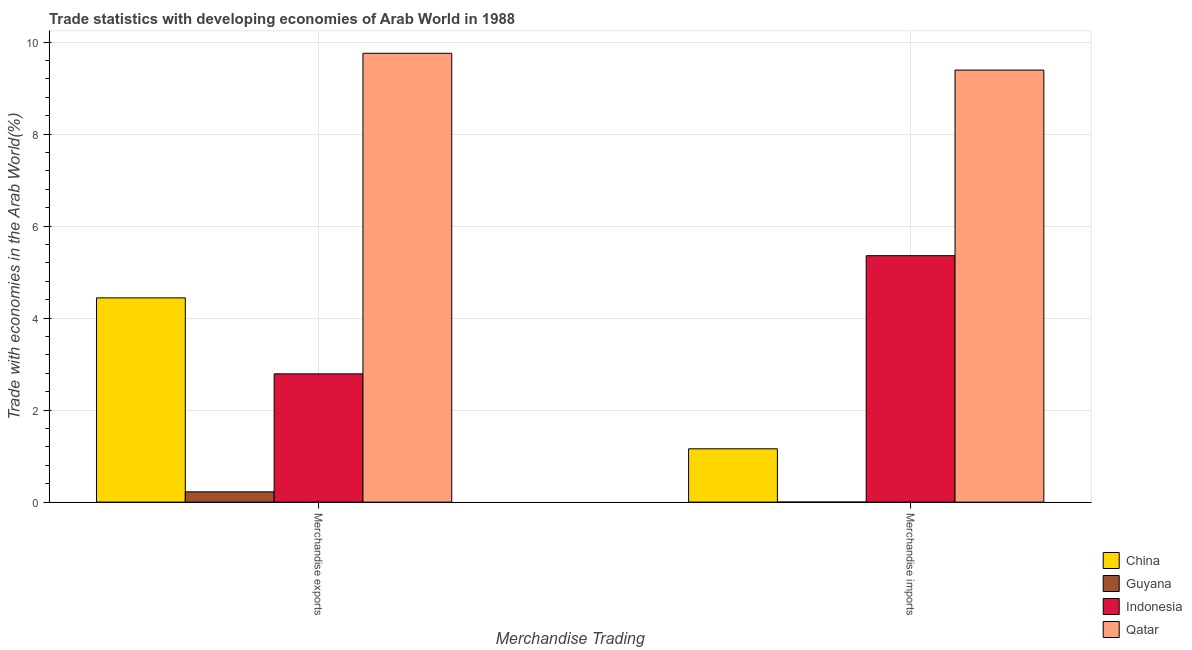How many different coloured bars are there?
Provide a short and direct response. 4. What is the merchandise exports in Qatar?
Ensure brevity in your answer.  9.76. Across all countries, what is the maximum merchandise imports?
Make the answer very short. 9.39. Across all countries, what is the minimum merchandise exports?
Offer a terse response. 0.22. In which country was the merchandise imports maximum?
Provide a short and direct response. Qatar. In which country was the merchandise imports minimum?
Give a very brief answer. Guyana. What is the total merchandise imports in the graph?
Provide a succinct answer. 15.91. What is the difference between the merchandise imports in Indonesia and that in Qatar?
Offer a terse response. -4.04. What is the difference between the merchandise imports in Qatar and the merchandise exports in Indonesia?
Provide a short and direct response. 6.61. What is the average merchandise exports per country?
Provide a short and direct response. 4.3. What is the difference between the merchandise imports and merchandise exports in China?
Offer a very short reply. -3.28. In how many countries, is the merchandise imports greater than 0.4 %?
Provide a short and direct response. 3. What is the ratio of the merchandise exports in Qatar to that in Guyana?
Ensure brevity in your answer.  43.6. Is the merchandise exports in China less than that in Qatar?
Provide a short and direct response. Yes. What does the 4th bar from the left in Merchandise imports represents?
Give a very brief answer. Qatar. What does the 3rd bar from the right in Merchandise exports represents?
Give a very brief answer. Guyana. Are all the bars in the graph horizontal?
Offer a terse response. No. What is the difference between two consecutive major ticks on the Y-axis?
Give a very brief answer. 2. Are the values on the major ticks of Y-axis written in scientific E-notation?
Keep it short and to the point. No. How many legend labels are there?
Make the answer very short. 4. How are the legend labels stacked?
Your answer should be very brief. Vertical. What is the title of the graph?
Make the answer very short. Trade statistics with developing economies of Arab World in 1988. Does "Sub-Saharan Africa (all income levels)" appear as one of the legend labels in the graph?
Offer a terse response. No. What is the label or title of the X-axis?
Your answer should be very brief. Merchandise Trading. What is the label or title of the Y-axis?
Provide a succinct answer. Trade with economies in the Arab World(%). What is the Trade with economies in the Arab World(%) in China in Merchandise exports?
Provide a succinct answer. 4.44. What is the Trade with economies in the Arab World(%) of Guyana in Merchandise exports?
Provide a succinct answer. 0.22. What is the Trade with economies in the Arab World(%) in Indonesia in Merchandise exports?
Provide a short and direct response. 2.79. What is the Trade with economies in the Arab World(%) in Qatar in Merchandise exports?
Provide a short and direct response. 9.76. What is the Trade with economies in the Arab World(%) in China in Merchandise imports?
Your response must be concise. 1.16. What is the Trade with economies in the Arab World(%) of Guyana in Merchandise imports?
Provide a short and direct response. 0. What is the Trade with economies in the Arab World(%) of Indonesia in Merchandise imports?
Ensure brevity in your answer.  5.36. What is the Trade with economies in the Arab World(%) of Qatar in Merchandise imports?
Your answer should be very brief. 9.39. Across all Merchandise Trading, what is the maximum Trade with economies in the Arab World(%) in China?
Provide a succinct answer. 4.44. Across all Merchandise Trading, what is the maximum Trade with economies in the Arab World(%) in Guyana?
Offer a very short reply. 0.22. Across all Merchandise Trading, what is the maximum Trade with economies in the Arab World(%) in Indonesia?
Ensure brevity in your answer.  5.36. Across all Merchandise Trading, what is the maximum Trade with economies in the Arab World(%) in Qatar?
Keep it short and to the point. 9.76. Across all Merchandise Trading, what is the minimum Trade with economies in the Arab World(%) in China?
Offer a terse response. 1.16. Across all Merchandise Trading, what is the minimum Trade with economies in the Arab World(%) in Guyana?
Give a very brief answer. 0. Across all Merchandise Trading, what is the minimum Trade with economies in the Arab World(%) of Indonesia?
Your answer should be very brief. 2.79. Across all Merchandise Trading, what is the minimum Trade with economies in the Arab World(%) of Qatar?
Offer a terse response. 9.39. What is the total Trade with economies in the Arab World(%) in China in the graph?
Offer a terse response. 5.6. What is the total Trade with economies in the Arab World(%) in Guyana in the graph?
Your answer should be very brief. 0.22. What is the total Trade with economies in the Arab World(%) of Indonesia in the graph?
Offer a terse response. 8.15. What is the total Trade with economies in the Arab World(%) in Qatar in the graph?
Provide a short and direct response. 19.15. What is the difference between the Trade with economies in the Arab World(%) in China in Merchandise exports and that in Merchandise imports?
Offer a terse response. 3.28. What is the difference between the Trade with economies in the Arab World(%) of Guyana in Merchandise exports and that in Merchandise imports?
Keep it short and to the point. 0.22. What is the difference between the Trade with economies in the Arab World(%) of Indonesia in Merchandise exports and that in Merchandise imports?
Keep it short and to the point. -2.57. What is the difference between the Trade with economies in the Arab World(%) in Qatar in Merchandise exports and that in Merchandise imports?
Ensure brevity in your answer.  0.37. What is the difference between the Trade with economies in the Arab World(%) of China in Merchandise exports and the Trade with economies in the Arab World(%) of Guyana in Merchandise imports?
Provide a short and direct response. 4.44. What is the difference between the Trade with economies in the Arab World(%) in China in Merchandise exports and the Trade with economies in the Arab World(%) in Indonesia in Merchandise imports?
Provide a short and direct response. -0.92. What is the difference between the Trade with economies in the Arab World(%) of China in Merchandise exports and the Trade with economies in the Arab World(%) of Qatar in Merchandise imports?
Your answer should be very brief. -4.95. What is the difference between the Trade with economies in the Arab World(%) in Guyana in Merchandise exports and the Trade with economies in the Arab World(%) in Indonesia in Merchandise imports?
Your answer should be compact. -5.13. What is the difference between the Trade with economies in the Arab World(%) of Guyana in Merchandise exports and the Trade with economies in the Arab World(%) of Qatar in Merchandise imports?
Keep it short and to the point. -9.17. What is the difference between the Trade with economies in the Arab World(%) in Indonesia in Merchandise exports and the Trade with economies in the Arab World(%) in Qatar in Merchandise imports?
Give a very brief answer. -6.61. What is the average Trade with economies in the Arab World(%) of China per Merchandise Trading?
Give a very brief answer. 2.8. What is the average Trade with economies in the Arab World(%) of Guyana per Merchandise Trading?
Give a very brief answer. 0.11. What is the average Trade with economies in the Arab World(%) in Indonesia per Merchandise Trading?
Make the answer very short. 4.07. What is the average Trade with economies in the Arab World(%) in Qatar per Merchandise Trading?
Keep it short and to the point. 9.58. What is the difference between the Trade with economies in the Arab World(%) in China and Trade with economies in the Arab World(%) in Guyana in Merchandise exports?
Offer a very short reply. 4.22. What is the difference between the Trade with economies in the Arab World(%) in China and Trade with economies in the Arab World(%) in Indonesia in Merchandise exports?
Your answer should be very brief. 1.65. What is the difference between the Trade with economies in the Arab World(%) of China and Trade with economies in the Arab World(%) of Qatar in Merchandise exports?
Your response must be concise. -5.32. What is the difference between the Trade with economies in the Arab World(%) of Guyana and Trade with economies in the Arab World(%) of Indonesia in Merchandise exports?
Provide a succinct answer. -2.57. What is the difference between the Trade with economies in the Arab World(%) in Guyana and Trade with economies in the Arab World(%) in Qatar in Merchandise exports?
Give a very brief answer. -9.54. What is the difference between the Trade with economies in the Arab World(%) in Indonesia and Trade with economies in the Arab World(%) in Qatar in Merchandise exports?
Give a very brief answer. -6.97. What is the difference between the Trade with economies in the Arab World(%) of China and Trade with economies in the Arab World(%) of Guyana in Merchandise imports?
Provide a short and direct response. 1.16. What is the difference between the Trade with economies in the Arab World(%) in China and Trade with economies in the Arab World(%) in Indonesia in Merchandise imports?
Make the answer very short. -4.2. What is the difference between the Trade with economies in the Arab World(%) of China and Trade with economies in the Arab World(%) of Qatar in Merchandise imports?
Keep it short and to the point. -8.23. What is the difference between the Trade with economies in the Arab World(%) in Guyana and Trade with economies in the Arab World(%) in Indonesia in Merchandise imports?
Ensure brevity in your answer.  -5.36. What is the difference between the Trade with economies in the Arab World(%) in Guyana and Trade with economies in the Arab World(%) in Qatar in Merchandise imports?
Provide a succinct answer. -9.39. What is the difference between the Trade with economies in the Arab World(%) in Indonesia and Trade with economies in the Arab World(%) in Qatar in Merchandise imports?
Offer a terse response. -4.04. What is the ratio of the Trade with economies in the Arab World(%) of China in Merchandise exports to that in Merchandise imports?
Your answer should be very brief. 3.83. What is the ratio of the Trade with economies in the Arab World(%) of Guyana in Merchandise exports to that in Merchandise imports?
Offer a very short reply. 558.79. What is the ratio of the Trade with economies in the Arab World(%) of Indonesia in Merchandise exports to that in Merchandise imports?
Keep it short and to the point. 0.52. What is the ratio of the Trade with economies in the Arab World(%) of Qatar in Merchandise exports to that in Merchandise imports?
Offer a very short reply. 1.04. What is the difference between the highest and the second highest Trade with economies in the Arab World(%) of China?
Your answer should be compact. 3.28. What is the difference between the highest and the second highest Trade with economies in the Arab World(%) in Guyana?
Offer a very short reply. 0.22. What is the difference between the highest and the second highest Trade with economies in the Arab World(%) in Indonesia?
Your answer should be compact. 2.57. What is the difference between the highest and the second highest Trade with economies in the Arab World(%) in Qatar?
Give a very brief answer. 0.37. What is the difference between the highest and the lowest Trade with economies in the Arab World(%) in China?
Provide a short and direct response. 3.28. What is the difference between the highest and the lowest Trade with economies in the Arab World(%) in Guyana?
Your response must be concise. 0.22. What is the difference between the highest and the lowest Trade with economies in the Arab World(%) in Indonesia?
Give a very brief answer. 2.57. What is the difference between the highest and the lowest Trade with economies in the Arab World(%) in Qatar?
Ensure brevity in your answer.  0.37. 